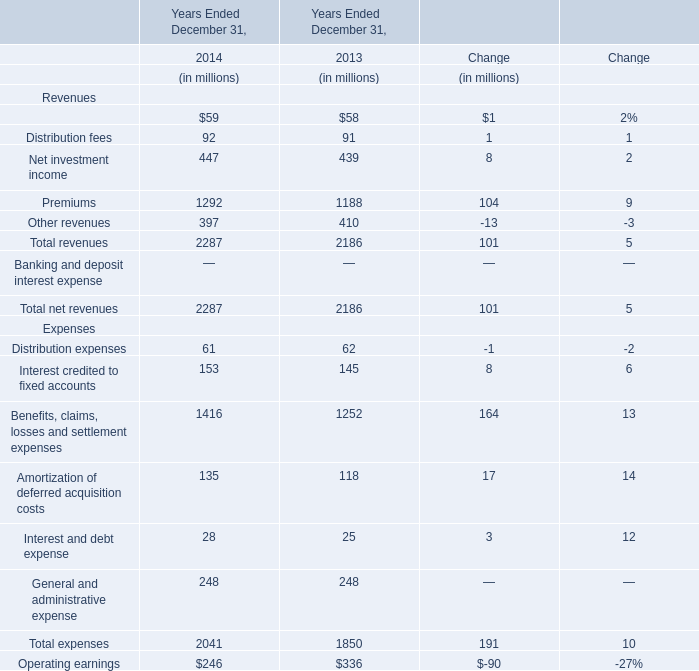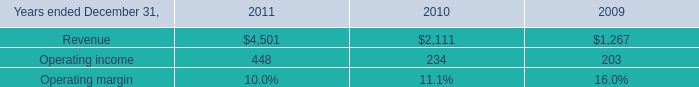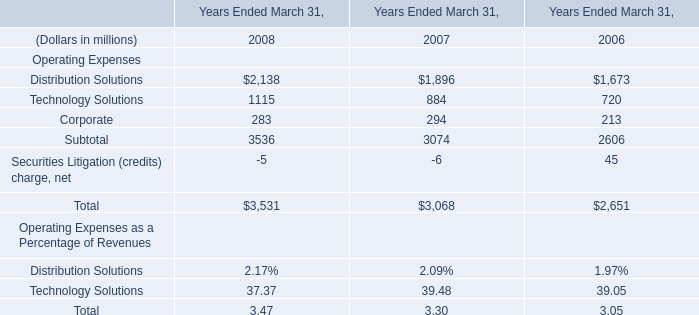What's the average of distribution fees in 2014 and 2013? (in million) 
Computations: ((92 + 91) / 2)
Answer: 91.5. 